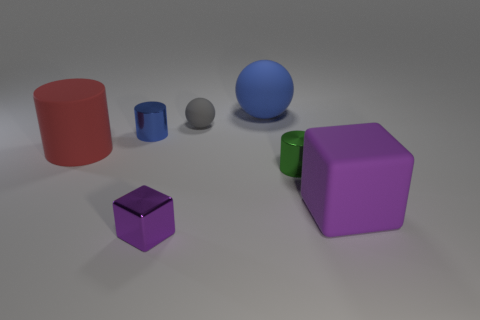Add 3 small cubes. How many objects exist? 10 Subtract all cubes. How many objects are left? 5 Subtract 0 cyan cubes. How many objects are left? 7 Subtract all tiny balls. Subtract all red cylinders. How many objects are left? 5 Add 6 big red rubber cylinders. How many big red rubber cylinders are left? 7 Add 4 large gray rubber spheres. How many large gray rubber spheres exist? 4 